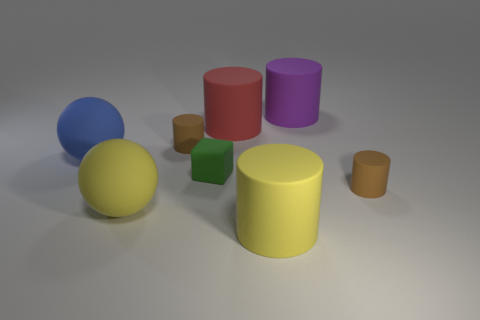Is the shape of the small brown thing that is in front of the green object the same as  the large red rubber thing?
Offer a very short reply. Yes. Is there a blue matte thing of the same shape as the small green rubber object?
Offer a very short reply. No. The small brown rubber object that is behind the tiny thing that is to the right of the big yellow cylinder is what shape?
Give a very brief answer. Cylinder. What number of small yellow things have the same material as the yellow sphere?
Keep it short and to the point. 0. There is a sphere that is the same material as the large blue object; what is its color?
Keep it short and to the point. Yellow. There is a blue rubber object that is behind the tiny brown object that is in front of the tiny object that is to the left of the small block; what is its size?
Your answer should be very brief. Large. Are there fewer big blue spheres than tiny gray cubes?
Your response must be concise. No. What is the color of the other rubber object that is the same shape as the large blue rubber object?
Offer a terse response. Yellow. There is a cylinder that is in front of the tiny brown matte object that is right of the big red cylinder; are there any blue things right of it?
Provide a succinct answer. No. Is the shape of the large red thing the same as the green rubber thing?
Your answer should be very brief. No. 